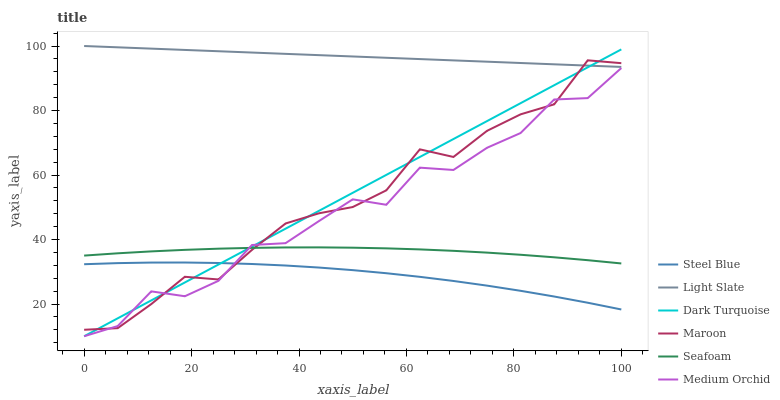Does Steel Blue have the minimum area under the curve?
Answer yes or no. Yes. Does Light Slate have the maximum area under the curve?
Answer yes or no. Yes. Does Dark Turquoise have the minimum area under the curve?
Answer yes or no. No. Does Dark Turquoise have the maximum area under the curve?
Answer yes or no. No. Is Dark Turquoise the smoothest?
Answer yes or no. Yes. Is Medium Orchid the roughest?
Answer yes or no. Yes. Is Medium Orchid the smoothest?
Answer yes or no. No. Is Dark Turquoise the roughest?
Answer yes or no. No. Does Steel Blue have the lowest value?
Answer yes or no. No. Does Light Slate have the highest value?
Answer yes or no. Yes. Does Dark Turquoise have the highest value?
Answer yes or no. No. Is Medium Orchid less than Light Slate?
Answer yes or no. Yes. Is Light Slate greater than Seafoam?
Answer yes or no. Yes. Does Dark Turquoise intersect Medium Orchid?
Answer yes or no. Yes. Is Dark Turquoise less than Medium Orchid?
Answer yes or no. No. Is Dark Turquoise greater than Medium Orchid?
Answer yes or no. No. Does Medium Orchid intersect Light Slate?
Answer yes or no. No. 